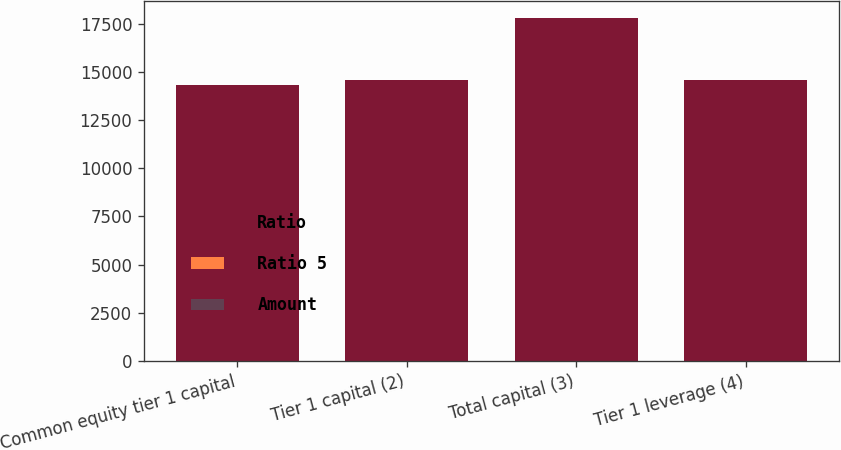<chart> <loc_0><loc_0><loc_500><loc_500><stacked_bar_chart><ecel><fcel>Common equity tier 1 capital<fcel>Tier 1 capital (2)<fcel>Total capital (3)<fcel>Tier 1 leverage (4)<nl><fcel>Ratio<fcel>14309<fcel>14556<fcel>17781<fcel>14556<nl><fcel>Ratio 5<fcel>11.2<fcel>11.4<fcel>13.9<fcel>10<nl><fcel>Amount<fcel>5.75<fcel>7.25<fcel>9.25<fcel>4<nl></chart> 